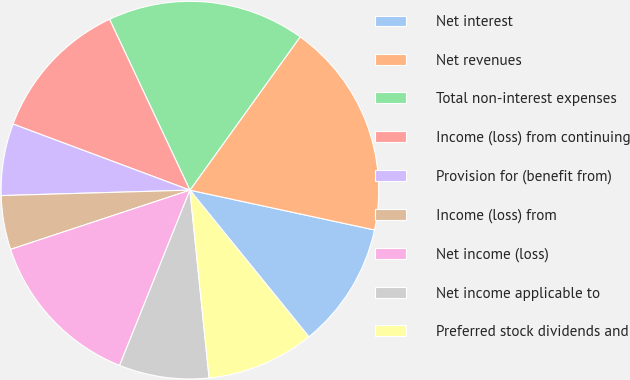Convert chart to OTSL. <chart><loc_0><loc_0><loc_500><loc_500><pie_chart><fcel>Net interest<fcel>Net revenues<fcel>Total non-interest expenses<fcel>Income (loss) from continuing<fcel>Provision for (benefit from)<fcel>Income (loss) from<fcel>Net income (loss)<fcel>Net income applicable to<fcel>Preferred stock dividends and<nl><fcel>10.77%<fcel>18.46%<fcel>16.92%<fcel>12.31%<fcel>6.15%<fcel>4.62%<fcel>13.85%<fcel>7.69%<fcel>9.23%<nl></chart> 